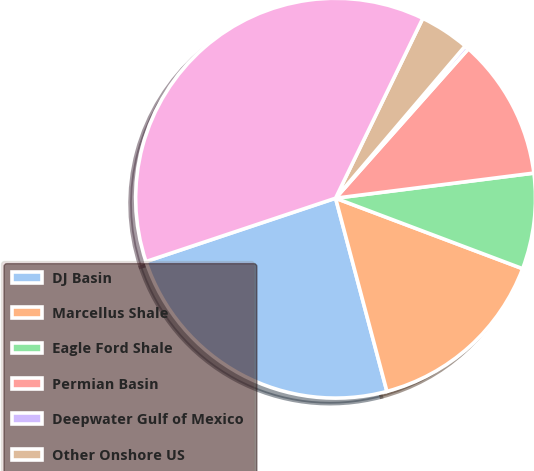Convert chart. <chart><loc_0><loc_0><loc_500><loc_500><pie_chart><fcel>DJ Basin<fcel>Marcellus Shale<fcel>Eagle Ford Shale<fcel>Permian Basin<fcel>Deepwater Gulf of Mexico<fcel>Other Onshore US<fcel>Total<nl><fcel>24.0%<fcel>15.13%<fcel>7.74%<fcel>11.43%<fcel>0.34%<fcel>4.04%<fcel>37.32%<nl></chart> 